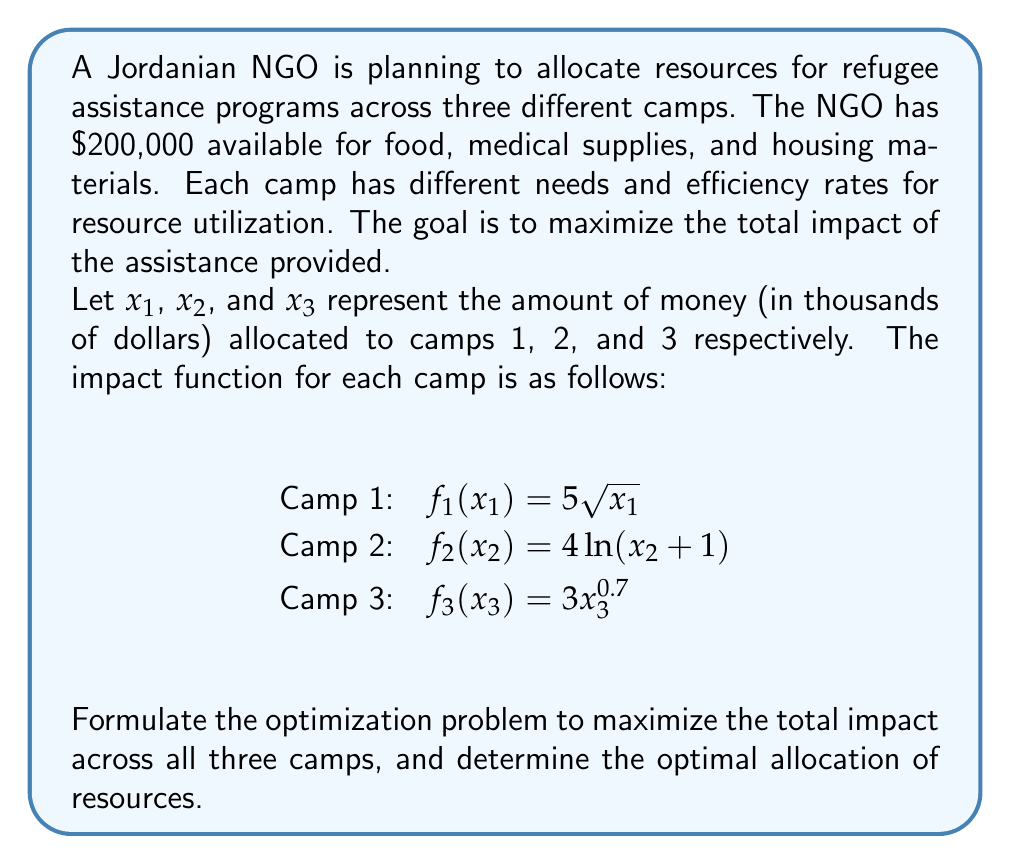Show me your answer to this math problem. To solve this problem, we need to formulate an optimization model and then use the Karush-Kuhn-Tucker (KKT) conditions to find the optimal solution. Let's go through this step-by-step:

1. Formulate the optimization problem:

Maximize: $Z = 5\sqrt{x_1} + 4\ln(x_2 + 1) + 3x_3^{0.7}$
Subject to: $x_1 + x_2 + x_3 \leq 200$
             $x_1, x_2, x_3 \geq 0$

2. Write the Lagrangian function:

$L(x_1, x_2, x_3, \lambda) = 5\sqrt{x_1} + 4\ln(x_2 + 1) + 3x_3^{0.7} + \lambda(200 - x_1 - x_2 - x_3)$

3. Apply the KKT conditions:

$$\frac{\partial L}{\partial x_1} = \frac{5}{2\sqrt{x_1}} - \lambda = 0$$
$$\frac{\partial L}{\partial x_2} = \frac{4}{x_2 + 1} - \lambda = 0$$
$$\frac{\partial L}{\partial x_3} = \frac{2.1}{x_3^{0.3}} - \lambda = 0$$
$$\frac{\partial L}{\partial \lambda} = 200 - x_1 - x_2 - x_3 = 0$$

4. Solve the system of equations:

From the first three equations:
$$x_1 = \frac{25}{4\lambda^2}$$
$$x_2 = \frac{4}{\lambda} - 1$$
$$x_3 = \left(\frac{2.1}{\lambda}\right)^{10/3}$$

Substitute these into the fourth equation:

$$200 = \frac{25}{4\lambda^2} + \frac{4}{\lambda} - 1 + \left(\frac{2.1}{\lambda}\right)^{10/3}$$

5. Solve this equation numerically (using a computer or calculator) to find $\lambda \approx 0.1986$.

6. Substitute this value back into the expressions for $x_1$, $x_2$, and $x_3$:

$$x_1 \approx 79.37$$
$$x_2 \approx 19.14$$
$$x_3 \approx 101.49$$

7. Round the values to the nearest thousand dollars:

$x_1 = 79,000$
$x_2 = 19,000$
$x_3 = 102,000$

These allocations sum to $200,000, which satisfies our budget constraint.
Answer: The optimal allocation of resources is:
Camp 1: $79,000
Camp 2: $19,000
Camp 3: $102,000
This allocation maximizes the total impact across all three refugee camps given the available budget of $200,000. 